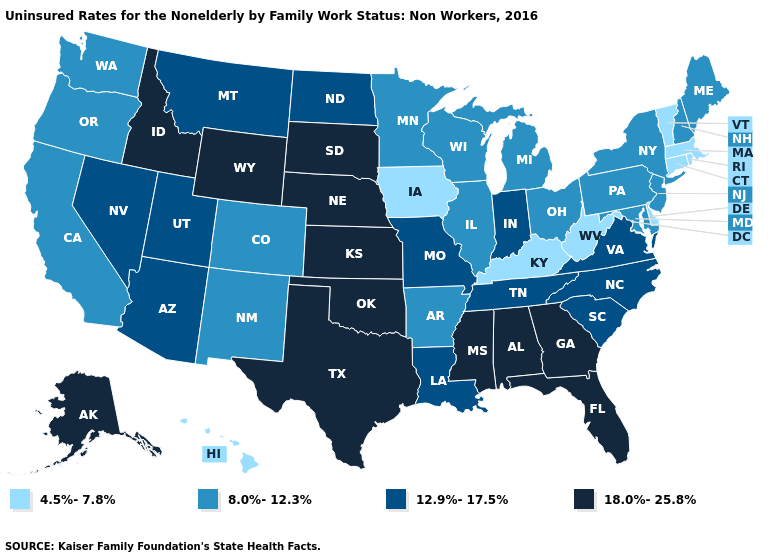Is the legend a continuous bar?
Keep it brief. No. What is the value of Arkansas?
Quick response, please. 8.0%-12.3%. Among the states that border Nebraska , which have the highest value?
Give a very brief answer. Kansas, South Dakota, Wyoming. How many symbols are there in the legend?
Short answer required. 4. Does New Hampshire have a higher value than Connecticut?
Keep it brief. Yes. Name the states that have a value in the range 8.0%-12.3%?
Be succinct. Arkansas, California, Colorado, Illinois, Maine, Maryland, Michigan, Minnesota, New Hampshire, New Jersey, New Mexico, New York, Ohio, Oregon, Pennsylvania, Washington, Wisconsin. Does Wisconsin have the lowest value in the USA?
Give a very brief answer. No. Name the states that have a value in the range 8.0%-12.3%?
Write a very short answer. Arkansas, California, Colorado, Illinois, Maine, Maryland, Michigan, Minnesota, New Hampshire, New Jersey, New Mexico, New York, Ohio, Oregon, Pennsylvania, Washington, Wisconsin. Does Georgia have a lower value than New Jersey?
Short answer required. No. Does Iowa have the lowest value in the MidWest?
Write a very short answer. Yes. What is the value of Pennsylvania?
Answer briefly. 8.0%-12.3%. What is the value of Colorado?
Write a very short answer. 8.0%-12.3%. Which states hav the highest value in the South?
Quick response, please. Alabama, Florida, Georgia, Mississippi, Oklahoma, Texas. Does the map have missing data?
Concise answer only. No. Name the states that have a value in the range 4.5%-7.8%?
Keep it brief. Connecticut, Delaware, Hawaii, Iowa, Kentucky, Massachusetts, Rhode Island, Vermont, West Virginia. 